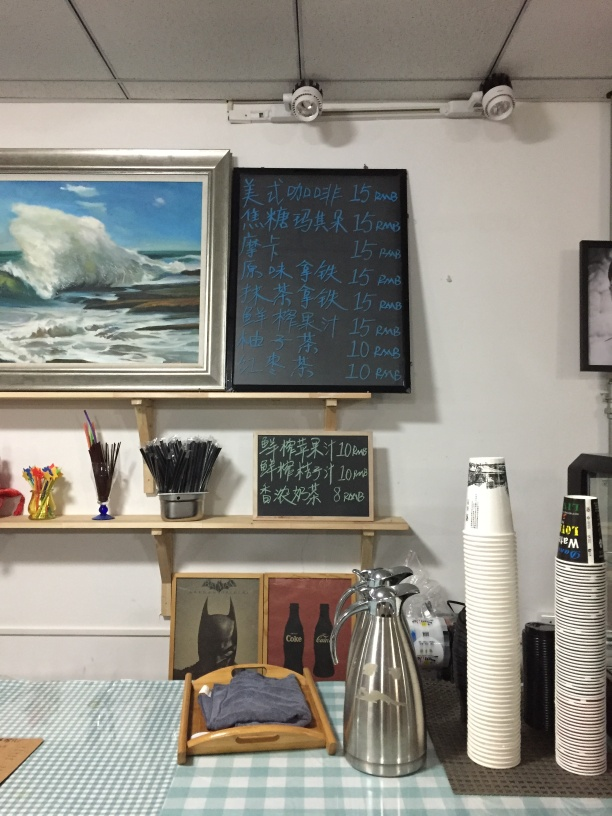What can you infer about the atmosphere of this place based on the image? The image suggests a casual and artistic atmosphere, evidenced by the displayed painting and the arrangement of simple furniture and art supplies. It appears to be a creative space, possibly a café or studio that also serves drinks. Does anything in the image suggest this place serves more than just drinks? Aside from the drinks menu, there's no direct indication that this establishment serves food or other items. However, the cozy setup with cups and a thermos implies a place where customers may spend time relaxing or socializing. 